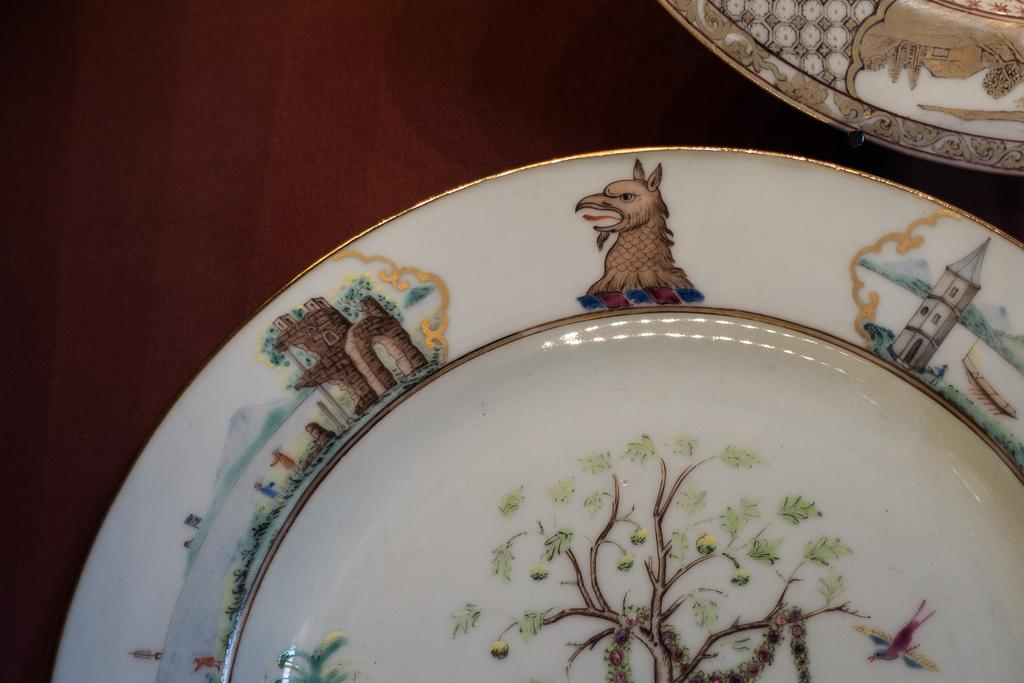How many plates are visible on the table in the image? There are two plates on the table in the image. Where was the image taken? The image was taken in a room. Are the plates covered with a veil in the image? There is no veil present in the image; the plates are visible. How many sisters are depicted in the image? There is no mention of sisters in the image, as the facts only mention the presence of two plates on a table in a room. 